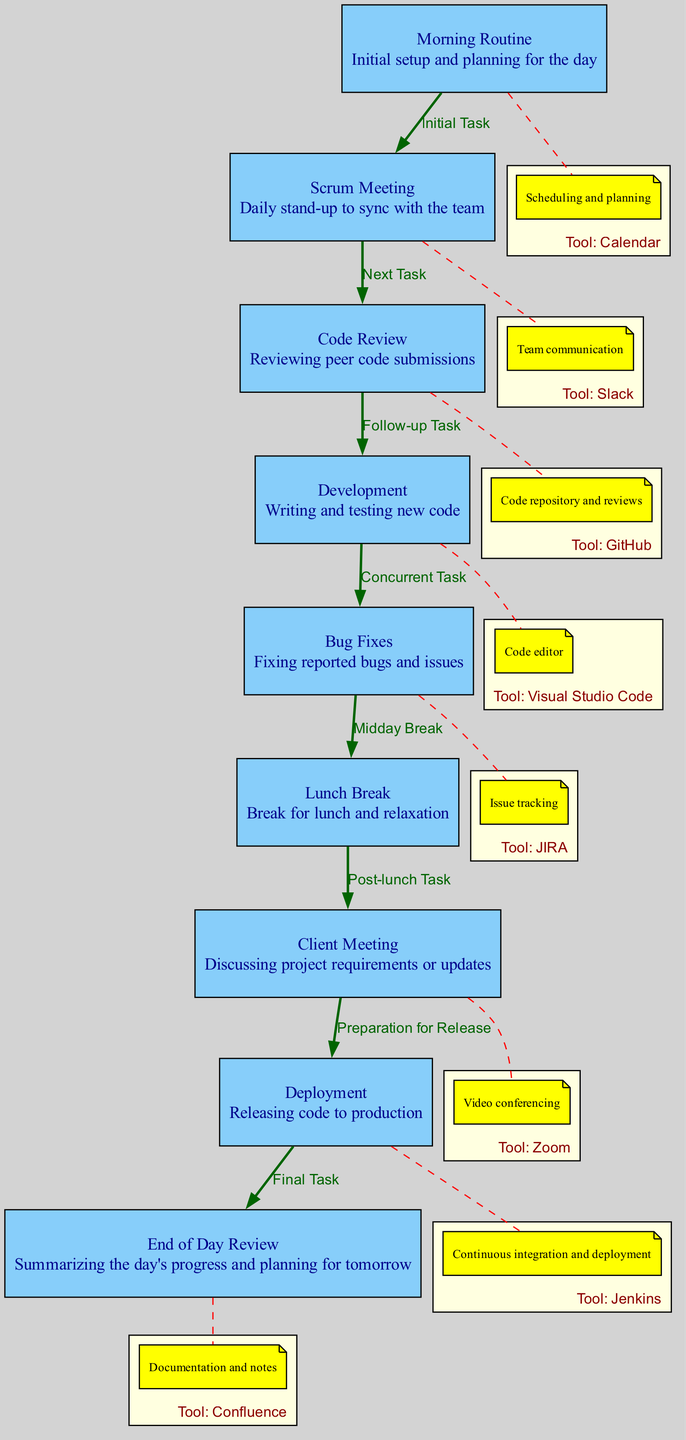What is the first task in the workflow? The first task listed in the diagram is "Morning Routine," which is indicated as the initial setup and planning step in the workflow.
Answer: Morning Routine How many nodes are there in the diagram? The diagram contains eight unique nodes: Morning Routine, Scrum Meeting, Code Review, Development, Bug Fixes, Lunch Break, Client Meeting, Deployment, and End of Day Review. Counting them gives a total of eight nodes.
Answer: Eight What tool is used for code review? According to the diagram, the tool associated with the "Code Review" node is "GitHub," which is used for reviewing peer code submissions.
Answer: GitHub Which task follows after the lunch break? The task that follows "Lunch Break" is "Client Meeting," as shown by the connecting edge labeled "Post-lunch Task."
Answer: Client Meeting How many edges connect the nodes? There are eight edges in the diagram that connect various nodes, indicating the flow from one task to the next. Each labeled connection represents either a task sequence or a relationship between tasks.
Answer: Eight What is the final task of the day? The diagram indicates that the final task at the end of the workflow is "End of Day Review," where the software engineer summarizes the day's progress and plans for tomorrow.
Answer: End of Day Review Which tool is associated with deployment? The tool indicated for the "Deployment" node is "Jenkins," which is used for continuous integration and deployment processes in the workflow.
Answer: Jenkins What relationship exists between bug fixes and lunch break? The diagram outlines a relationship where the "Bug Fixes" task leads into "Lunch Break," labeled as "Midday Break," indicating that bug fixing occurs before taking a break for lunch.
Answer: Midday Break 